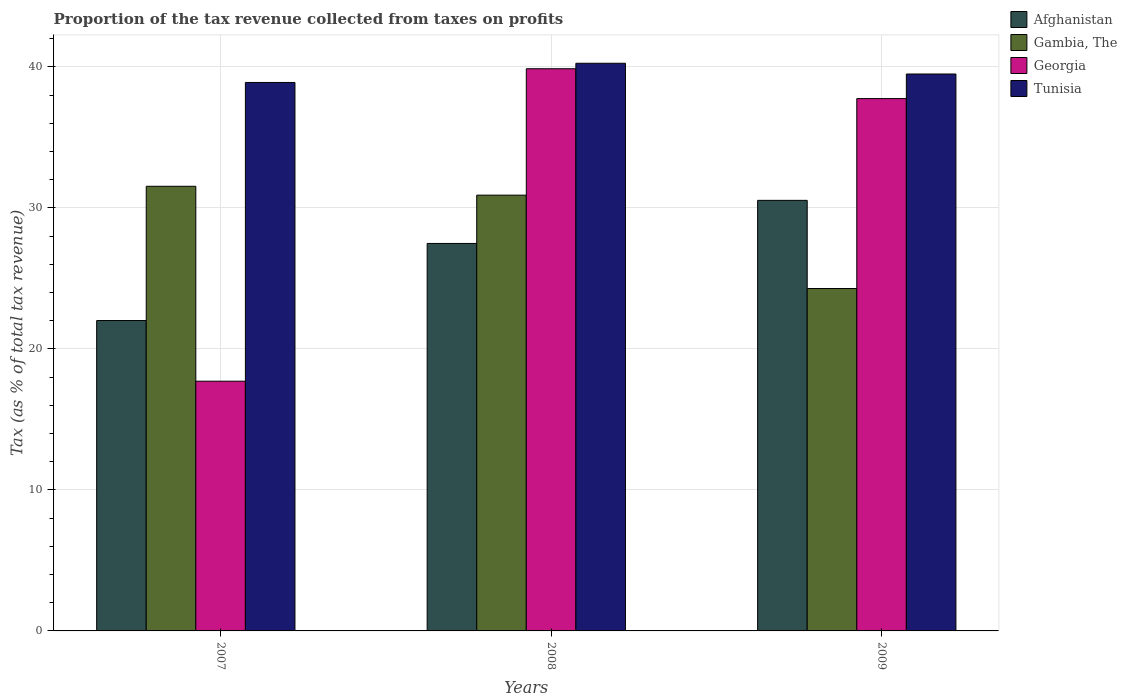How many bars are there on the 2nd tick from the left?
Provide a short and direct response. 4. What is the label of the 1st group of bars from the left?
Your response must be concise. 2007. What is the proportion of the tax revenue collected in Georgia in 2008?
Provide a succinct answer. 39.86. Across all years, what is the maximum proportion of the tax revenue collected in Gambia, The?
Your answer should be very brief. 31.53. Across all years, what is the minimum proportion of the tax revenue collected in Gambia, The?
Make the answer very short. 24.28. In which year was the proportion of the tax revenue collected in Gambia, The minimum?
Ensure brevity in your answer.  2009. What is the total proportion of the tax revenue collected in Afghanistan in the graph?
Your answer should be compact. 80.02. What is the difference between the proportion of the tax revenue collected in Afghanistan in 2007 and that in 2008?
Your answer should be very brief. -5.47. What is the difference between the proportion of the tax revenue collected in Tunisia in 2008 and the proportion of the tax revenue collected in Afghanistan in 2009?
Ensure brevity in your answer.  9.72. What is the average proportion of the tax revenue collected in Afghanistan per year?
Offer a terse response. 26.67. In the year 2008, what is the difference between the proportion of the tax revenue collected in Gambia, The and proportion of the tax revenue collected in Tunisia?
Make the answer very short. -9.35. What is the ratio of the proportion of the tax revenue collected in Georgia in 2007 to that in 2008?
Make the answer very short. 0.44. Is the proportion of the tax revenue collected in Afghanistan in 2007 less than that in 2008?
Your answer should be compact. Yes. What is the difference between the highest and the second highest proportion of the tax revenue collected in Afghanistan?
Provide a succinct answer. 3.06. What is the difference between the highest and the lowest proportion of the tax revenue collected in Afghanistan?
Offer a very short reply. 8.52. Is the sum of the proportion of the tax revenue collected in Tunisia in 2008 and 2009 greater than the maximum proportion of the tax revenue collected in Gambia, The across all years?
Offer a terse response. Yes. Is it the case that in every year, the sum of the proportion of the tax revenue collected in Georgia and proportion of the tax revenue collected in Afghanistan is greater than the sum of proportion of the tax revenue collected in Tunisia and proportion of the tax revenue collected in Gambia, The?
Offer a terse response. No. What does the 3rd bar from the left in 2007 represents?
Offer a very short reply. Georgia. What does the 2nd bar from the right in 2009 represents?
Keep it short and to the point. Georgia. How many bars are there?
Your answer should be very brief. 12. How many years are there in the graph?
Provide a short and direct response. 3. Are the values on the major ticks of Y-axis written in scientific E-notation?
Your answer should be compact. No. How many legend labels are there?
Provide a short and direct response. 4. How are the legend labels stacked?
Keep it short and to the point. Vertical. What is the title of the graph?
Offer a very short reply. Proportion of the tax revenue collected from taxes on profits. Does "China" appear as one of the legend labels in the graph?
Offer a very short reply. No. What is the label or title of the Y-axis?
Provide a succinct answer. Tax (as % of total tax revenue). What is the Tax (as % of total tax revenue) in Afghanistan in 2007?
Your response must be concise. 22.01. What is the Tax (as % of total tax revenue) of Gambia, The in 2007?
Make the answer very short. 31.53. What is the Tax (as % of total tax revenue) of Georgia in 2007?
Ensure brevity in your answer.  17.71. What is the Tax (as % of total tax revenue) in Tunisia in 2007?
Provide a succinct answer. 38.89. What is the Tax (as % of total tax revenue) in Afghanistan in 2008?
Ensure brevity in your answer.  27.48. What is the Tax (as % of total tax revenue) in Gambia, The in 2008?
Your answer should be compact. 30.9. What is the Tax (as % of total tax revenue) in Georgia in 2008?
Provide a short and direct response. 39.86. What is the Tax (as % of total tax revenue) in Tunisia in 2008?
Provide a succinct answer. 40.25. What is the Tax (as % of total tax revenue) of Afghanistan in 2009?
Make the answer very short. 30.53. What is the Tax (as % of total tax revenue) of Gambia, The in 2009?
Ensure brevity in your answer.  24.28. What is the Tax (as % of total tax revenue) of Georgia in 2009?
Your response must be concise. 37.75. What is the Tax (as % of total tax revenue) in Tunisia in 2009?
Ensure brevity in your answer.  39.49. Across all years, what is the maximum Tax (as % of total tax revenue) of Afghanistan?
Ensure brevity in your answer.  30.53. Across all years, what is the maximum Tax (as % of total tax revenue) in Gambia, The?
Offer a very short reply. 31.53. Across all years, what is the maximum Tax (as % of total tax revenue) of Georgia?
Your answer should be compact. 39.86. Across all years, what is the maximum Tax (as % of total tax revenue) in Tunisia?
Provide a succinct answer. 40.25. Across all years, what is the minimum Tax (as % of total tax revenue) in Afghanistan?
Give a very brief answer. 22.01. Across all years, what is the minimum Tax (as % of total tax revenue) in Gambia, The?
Offer a terse response. 24.28. Across all years, what is the minimum Tax (as % of total tax revenue) of Georgia?
Keep it short and to the point. 17.71. Across all years, what is the minimum Tax (as % of total tax revenue) of Tunisia?
Provide a succinct answer. 38.89. What is the total Tax (as % of total tax revenue) in Afghanistan in the graph?
Offer a terse response. 80.02. What is the total Tax (as % of total tax revenue) of Gambia, The in the graph?
Provide a succinct answer. 86.71. What is the total Tax (as % of total tax revenue) in Georgia in the graph?
Provide a succinct answer. 95.32. What is the total Tax (as % of total tax revenue) in Tunisia in the graph?
Give a very brief answer. 118.63. What is the difference between the Tax (as % of total tax revenue) in Afghanistan in 2007 and that in 2008?
Offer a very short reply. -5.47. What is the difference between the Tax (as % of total tax revenue) of Gambia, The in 2007 and that in 2008?
Your answer should be very brief. 0.63. What is the difference between the Tax (as % of total tax revenue) in Georgia in 2007 and that in 2008?
Give a very brief answer. -22.15. What is the difference between the Tax (as % of total tax revenue) in Tunisia in 2007 and that in 2008?
Provide a succinct answer. -1.36. What is the difference between the Tax (as % of total tax revenue) of Afghanistan in 2007 and that in 2009?
Your response must be concise. -8.52. What is the difference between the Tax (as % of total tax revenue) in Gambia, The in 2007 and that in 2009?
Make the answer very short. 7.25. What is the difference between the Tax (as % of total tax revenue) of Georgia in 2007 and that in 2009?
Your answer should be compact. -20.04. What is the difference between the Tax (as % of total tax revenue) in Tunisia in 2007 and that in 2009?
Offer a terse response. -0.6. What is the difference between the Tax (as % of total tax revenue) in Afghanistan in 2008 and that in 2009?
Ensure brevity in your answer.  -3.06. What is the difference between the Tax (as % of total tax revenue) in Gambia, The in 2008 and that in 2009?
Keep it short and to the point. 6.62. What is the difference between the Tax (as % of total tax revenue) in Georgia in 2008 and that in 2009?
Offer a terse response. 2.12. What is the difference between the Tax (as % of total tax revenue) of Tunisia in 2008 and that in 2009?
Provide a succinct answer. 0.76. What is the difference between the Tax (as % of total tax revenue) in Afghanistan in 2007 and the Tax (as % of total tax revenue) in Gambia, The in 2008?
Offer a terse response. -8.89. What is the difference between the Tax (as % of total tax revenue) in Afghanistan in 2007 and the Tax (as % of total tax revenue) in Georgia in 2008?
Your answer should be very brief. -17.85. What is the difference between the Tax (as % of total tax revenue) of Afghanistan in 2007 and the Tax (as % of total tax revenue) of Tunisia in 2008?
Make the answer very short. -18.24. What is the difference between the Tax (as % of total tax revenue) in Gambia, The in 2007 and the Tax (as % of total tax revenue) in Georgia in 2008?
Make the answer very short. -8.33. What is the difference between the Tax (as % of total tax revenue) in Gambia, The in 2007 and the Tax (as % of total tax revenue) in Tunisia in 2008?
Give a very brief answer. -8.72. What is the difference between the Tax (as % of total tax revenue) in Georgia in 2007 and the Tax (as % of total tax revenue) in Tunisia in 2008?
Keep it short and to the point. -22.54. What is the difference between the Tax (as % of total tax revenue) in Afghanistan in 2007 and the Tax (as % of total tax revenue) in Gambia, The in 2009?
Offer a very short reply. -2.27. What is the difference between the Tax (as % of total tax revenue) of Afghanistan in 2007 and the Tax (as % of total tax revenue) of Georgia in 2009?
Offer a terse response. -15.74. What is the difference between the Tax (as % of total tax revenue) in Afghanistan in 2007 and the Tax (as % of total tax revenue) in Tunisia in 2009?
Provide a short and direct response. -17.48. What is the difference between the Tax (as % of total tax revenue) in Gambia, The in 2007 and the Tax (as % of total tax revenue) in Georgia in 2009?
Make the answer very short. -6.22. What is the difference between the Tax (as % of total tax revenue) of Gambia, The in 2007 and the Tax (as % of total tax revenue) of Tunisia in 2009?
Offer a very short reply. -7.96. What is the difference between the Tax (as % of total tax revenue) in Georgia in 2007 and the Tax (as % of total tax revenue) in Tunisia in 2009?
Keep it short and to the point. -21.78. What is the difference between the Tax (as % of total tax revenue) in Afghanistan in 2008 and the Tax (as % of total tax revenue) in Gambia, The in 2009?
Provide a short and direct response. 3.19. What is the difference between the Tax (as % of total tax revenue) in Afghanistan in 2008 and the Tax (as % of total tax revenue) in Georgia in 2009?
Your response must be concise. -10.27. What is the difference between the Tax (as % of total tax revenue) of Afghanistan in 2008 and the Tax (as % of total tax revenue) of Tunisia in 2009?
Make the answer very short. -12.02. What is the difference between the Tax (as % of total tax revenue) of Gambia, The in 2008 and the Tax (as % of total tax revenue) of Georgia in 2009?
Make the answer very short. -6.85. What is the difference between the Tax (as % of total tax revenue) of Gambia, The in 2008 and the Tax (as % of total tax revenue) of Tunisia in 2009?
Offer a terse response. -8.59. What is the difference between the Tax (as % of total tax revenue) in Georgia in 2008 and the Tax (as % of total tax revenue) in Tunisia in 2009?
Keep it short and to the point. 0.37. What is the average Tax (as % of total tax revenue) in Afghanistan per year?
Ensure brevity in your answer.  26.67. What is the average Tax (as % of total tax revenue) of Gambia, The per year?
Offer a terse response. 28.9. What is the average Tax (as % of total tax revenue) in Georgia per year?
Your response must be concise. 31.77. What is the average Tax (as % of total tax revenue) of Tunisia per year?
Offer a very short reply. 39.54. In the year 2007, what is the difference between the Tax (as % of total tax revenue) of Afghanistan and Tax (as % of total tax revenue) of Gambia, The?
Offer a terse response. -9.52. In the year 2007, what is the difference between the Tax (as % of total tax revenue) in Afghanistan and Tax (as % of total tax revenue) in Georgia?
Offer a very short reply. 4.3. In the year 2007, what is the difference between the Tax (as % of total tax revenue) in Afghanistan and Tax (as % of total tax revenue) in Tunisia?
Offer a terse response. -16.88. In the year 2007, what is the difference between the Tax (as % of total tax revenue) of Gambia, The and Tax (as % of total tax revenue) of Georgia?
Give a very brief answer. 13.82. In the year 2007, what is the difference between the Tax (as % of total tax revenue) of Gambia, The and Tax (as % of total tax revenue) of Tunisia?
Your answer should be compact. -7.36. In the year 2007, what is the difference between the Tax (as % of total tax revenue) in Georgia and Tax (as % of total tax revenue) in Tunisia?
Provide a short and direct response. -21.18. In the year 2008, what is the difference between the Tax (as % of total tax revenue) in Afghanistan and Tax (as % of total tax revenue) in Gambia, The?
Provide a succinct answer. -3.42. In the year 2008, what is the difference between the Tax (as % of total tax revenue) of Afghanistan and Tax (as % of total tax revenue) of Georgia?
Keep it short and to the point. -12.39. In the year 2008, what is the difference between the Tax (as % of total tax revenue) of Afghanistan and Tax (as % of total tax revenue) of Tunisia?
Your response must be concise. -12.78. In the year 2008, what is the difference between the Tax (as % of total tax revenue) in Gambia, The and Tax (as % of total tax revenue) in Georgia?
Provide a short and direct response. -8.96. In the year 2008, what is the difference between the Tax (as % of total tax revenue) in Gambia, The and Tax (as % of total tax revenue) in Tunisia?
Offer a terse response. -9.35. In the year 2008, what is the difference between the Tax (as % of total tax revenue) in Georgia and Tax (as % of total tax revenue) in Tunisia?
Offer a terse response. -0.39. In the year 2009, what is the difference between the Tax (as % of total tax revenue) in Afghanistan and Tax (as % of total tax revenue) in Gambia, The?
Your answer should be compact. 6.25. In the year 2009, what is the difference between the Tax (as % of total tax revenue) in Afghanistan and Tax (as % of total tax revenue) in Georgia?
Offer a terse response. -7.22. In the year 2009, what is the difference between the Tax (as % of total tax revenue) of Afghanistan and Tax (as % of total tax revenue) of Tunisia?
Your answer should be compact. -8.96. In the year 2009, what is the difference between the Tax (as % of total tax revenue) of Gambia, The and Tax (as % of total tax revenue) of Georgia?
Offer a terse response. -13.47. In the year 2009, what is the difference between the Tax (as % of total tax revenue) of Gambia, The and Tax (as % of total tax revenue) of Tunisia?
Your answer should be very brief. -15.21. In the year 2009, what is the difference between the Tax (as % of total tax revenue) of Georgia and Tax (as % of total tax revenue) of Tunisia?
Your answer should be compact. -1.74. What is the ratio of the Tax (as % of total tax revenue) of Afghanistan in 2007 to that in 2008?
Ensure brevity in your answer.  0.8. What is the ratio of the Tax (as % of total tax revenue) in Gambia, The in 2007 to that in 2008?
Offer a terse response. 1.02. What is the ratio of the Tax (as % of total tax revenue) of Georgia in 2007 to that in 2008?
Make the answer very short. 0.44. What is the ratio of the Tax (as % of total tax revenue) in Tunisia in 2007 to that in 2008?
Your answer should be compact. 0.97. What is the ratio of the Tax (as % of total tax revenue) in Afghanistan in 2007 to that in 2009?
Give a very brief answer. 0.72. What is the ratio of the Tax (as % of total tax revenue) in Gambia, The in 2007 to that in 2009?
Ensure brevity in your answer.  1.3. What is the ratio of the Tax (as % of total tax revenue) of Georgia in 2007 to that in 2009?
Provide a short and direct response. 0.47. What is the ratio of the Tax (as % of total tax revenue) of Afghanistan in 2008 to that in 2009?
Your answer should be compact. 0.9. What is the ratio of the Tax (as % of total tax revenue) in Gambia, The in 2008 to that in 2009?
Offer a terse response. 1.27. What is the ratio of the Tax (as % of total tax revenue) in Georgia in 2008 to that in 2009?
Your answer should be very brief. 1.06. What is the ratio of the Tax (as % of total tax revenue) of Tunisia in 2008 to that in 2009?
Offer a terse response. 1.02. What is the difference between the highest and the second highest Tax (as % of total tax revenue) in Afghanistan?
Give a very brief answer. 3.06. What is the difference between the highest and the second highest Tax (as % of total tax revenue) in Gambia, The?
Provide a succinct answer. 0.63. What is the difference between the highest and the second highest Tax (as % of total tax revenue) in Georgia?
Your response must be concise. 2.12. What is the difference between the highest and the second highest Tax (as % of total tax revenue) in Tunisia?
Provide a short and direct response. 0.76. What is the difference between the highest and the lowest Tax (as % of total tax revenue) in Afghanistan?
Provide a short and direct response. 8.52. What is the difference between the highest and the lowest Tax (as % of total tax revenue) of Gambia, The?
Offer a very short reply. 7.25. What is the difference between the highest and the lowest Tax (as % of total tax revenue) in Georgia?
Offer a terse response. 22.15. What is the difference between the highest and the lowest Tax (as % of total tax revenue) in Tunisia?
Provide a succinct answer. 1.36. 